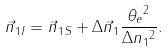Convert formula to latex. <formula><loc_0><loc_0><loc_500><loc_500>\vec { n } _ { 1 I } = \vec { n } _ { 1 S } + \Delta \vec { n } _ { 1 } \frac { { \theta _ { e } } ^ { 2 } } { \Delta { n _ { 1 } } ^ { 2 } } .</formula> 